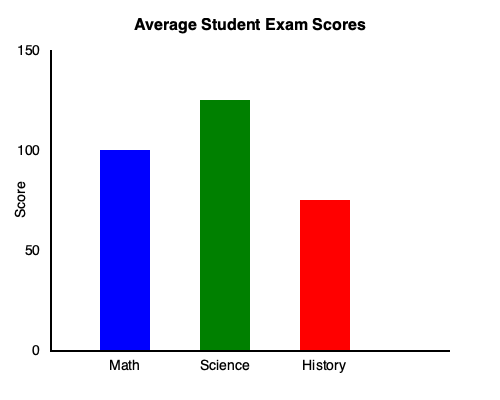Based on the bar graph showing average student exam scores, which subject has the highest average score, and what is the difference between the highest and lowest scores? To answer this question, we need to follow these steps:

1. Identify the subjects and their corresponding scores:
   - Math (blue bar): 100 points
   - Science (green bar): 125 points
   - History (red bar): 75 points

2. Determine the subject with the highest average score:
   Science has the tallest bar, reaching 125 points, so it has the highest average score.

3. Calculate the difference between the highest and lowest scores:
   - Highest score: Science with 125 points
   - Lowest score: History with 75 points
   - Difference: $125 - 75 = 50$ points

Therefore, Science has the highest average score, and the difference between the highest (Science) and lowest (History) scores is 50 points.
Answer: Science; 50 points 